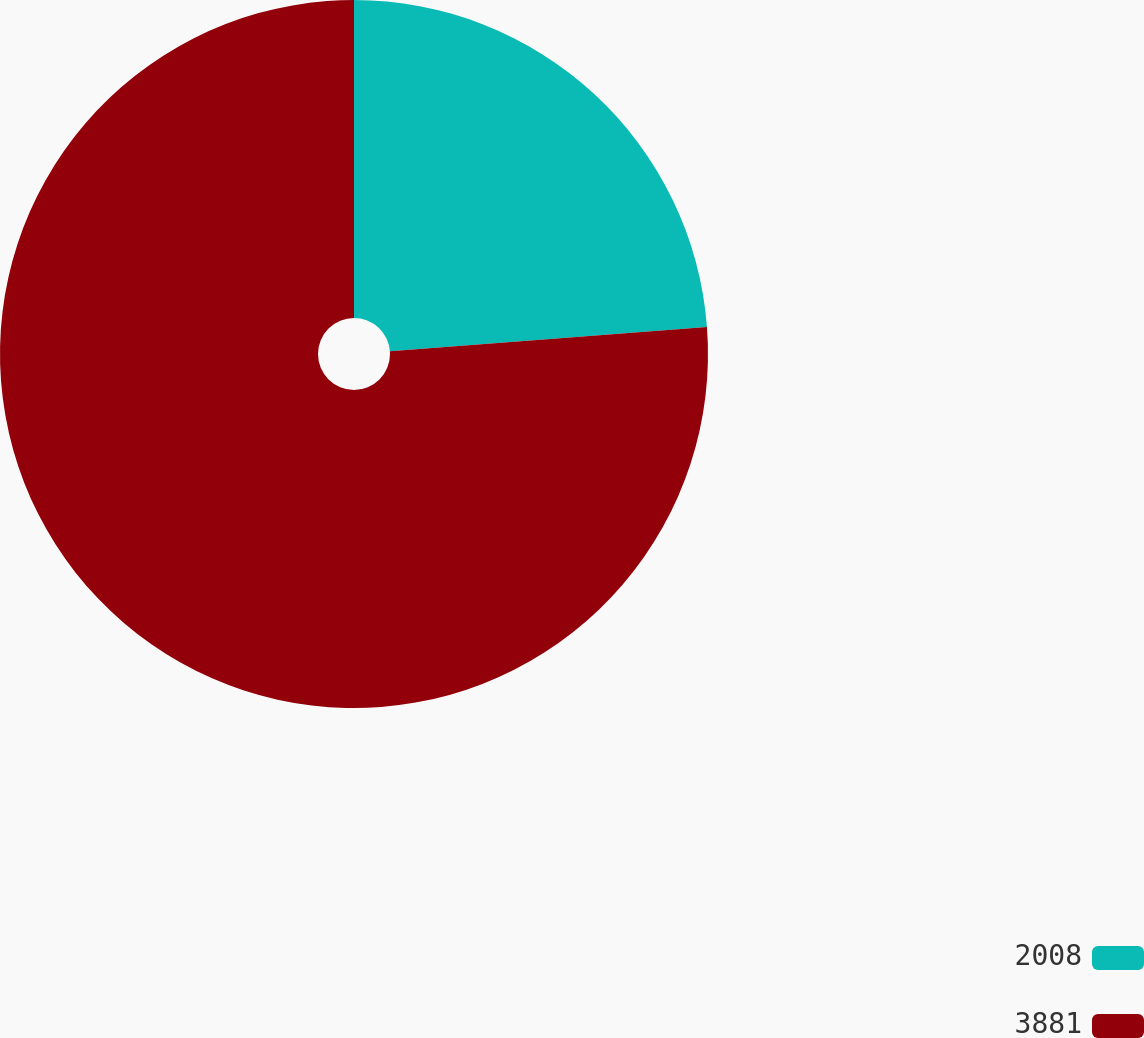<chart> <loc_0><loc_0><loc_500><loc_500><pie_chart><fcel>2008<fcel>3881<nl><fcel>23.78%<fcel>76.22%<nl></chart> 